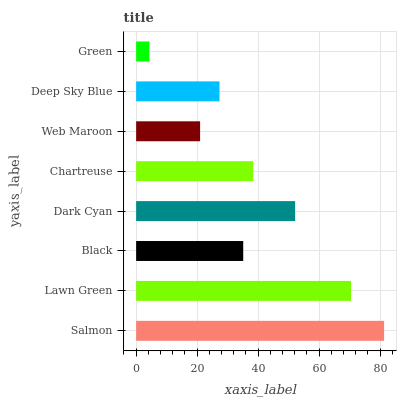Is Green the minimum?
Answer yes or no. Yes. Is Salmon the maximum?
Answer yes or no. Yes. Is Lawn Green the minimum?
Answer yes or no. No. Is Lawn Green the maximum?
Answer yes or no. No. Is Salmon greater than Lawn Green?
Answer yes or no. Yes. Is Lawn Green less than Salmon?
Answer yes or no. Yes. Is Lawn Green greater than Salmon?
Answer yes or no. No. Is Salmon less than Lawn Green?
Answer yes or no. No. Is Chartreuse the high median?
Answer yes or no. Yes. Is Black the low median?
Answer yes or no. Yes. Is Salmon the high median?
Answer yes or no. No. Is Chartreuse the low median?
Answer yes or no. No. 